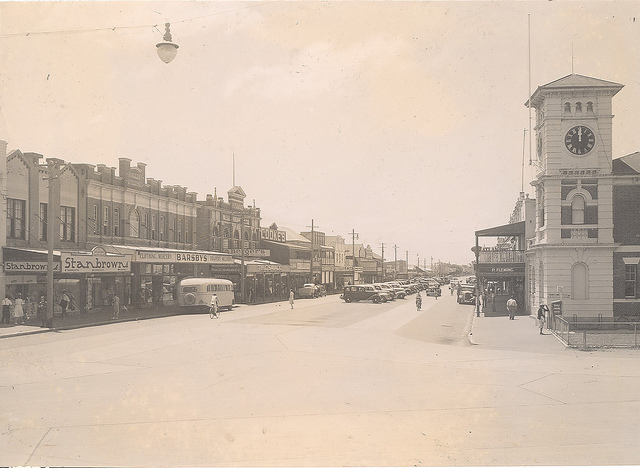<image>What architectural style is visible in the background? I am not sure what architectural style is visible in the background. It can be Victorian, American, Modern or Old West. What architectural style is visible in the background? I am not sure about the architectural style visible in the background. It can be Victorian, American, Modern, or something else. 